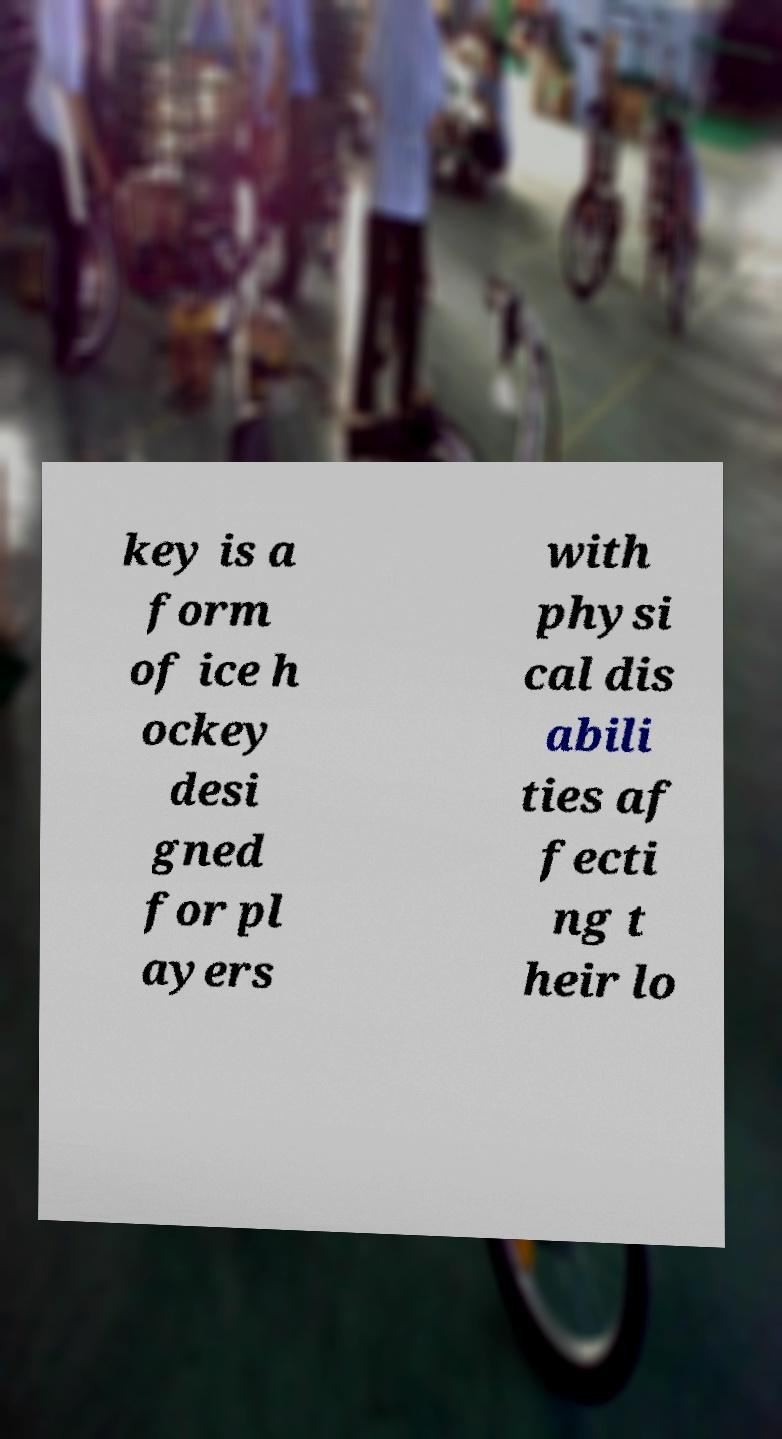There's text embedded in this image that I need extracted. Can you transcribe it verbatim? key is a form of ice h ockey desi gned for pl ayers with physi cal dis abili ties af fecti ng t heir lo 